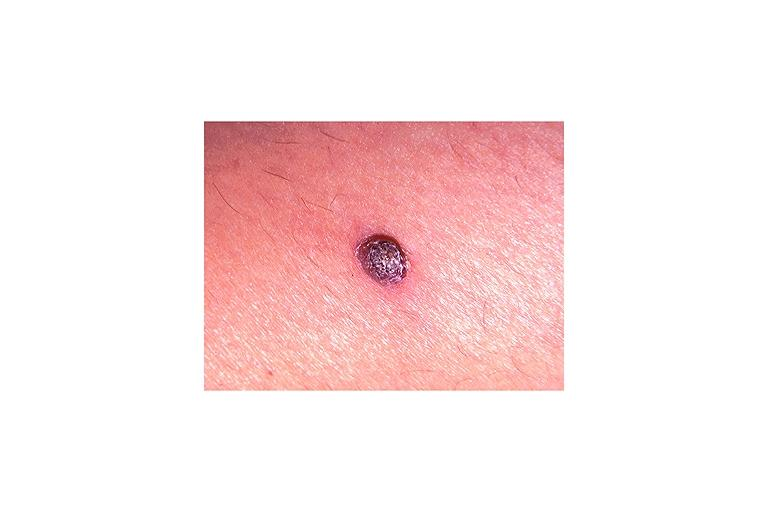what does this image show?
Answer the question using a single word or phrase. Verruca vulgaris 